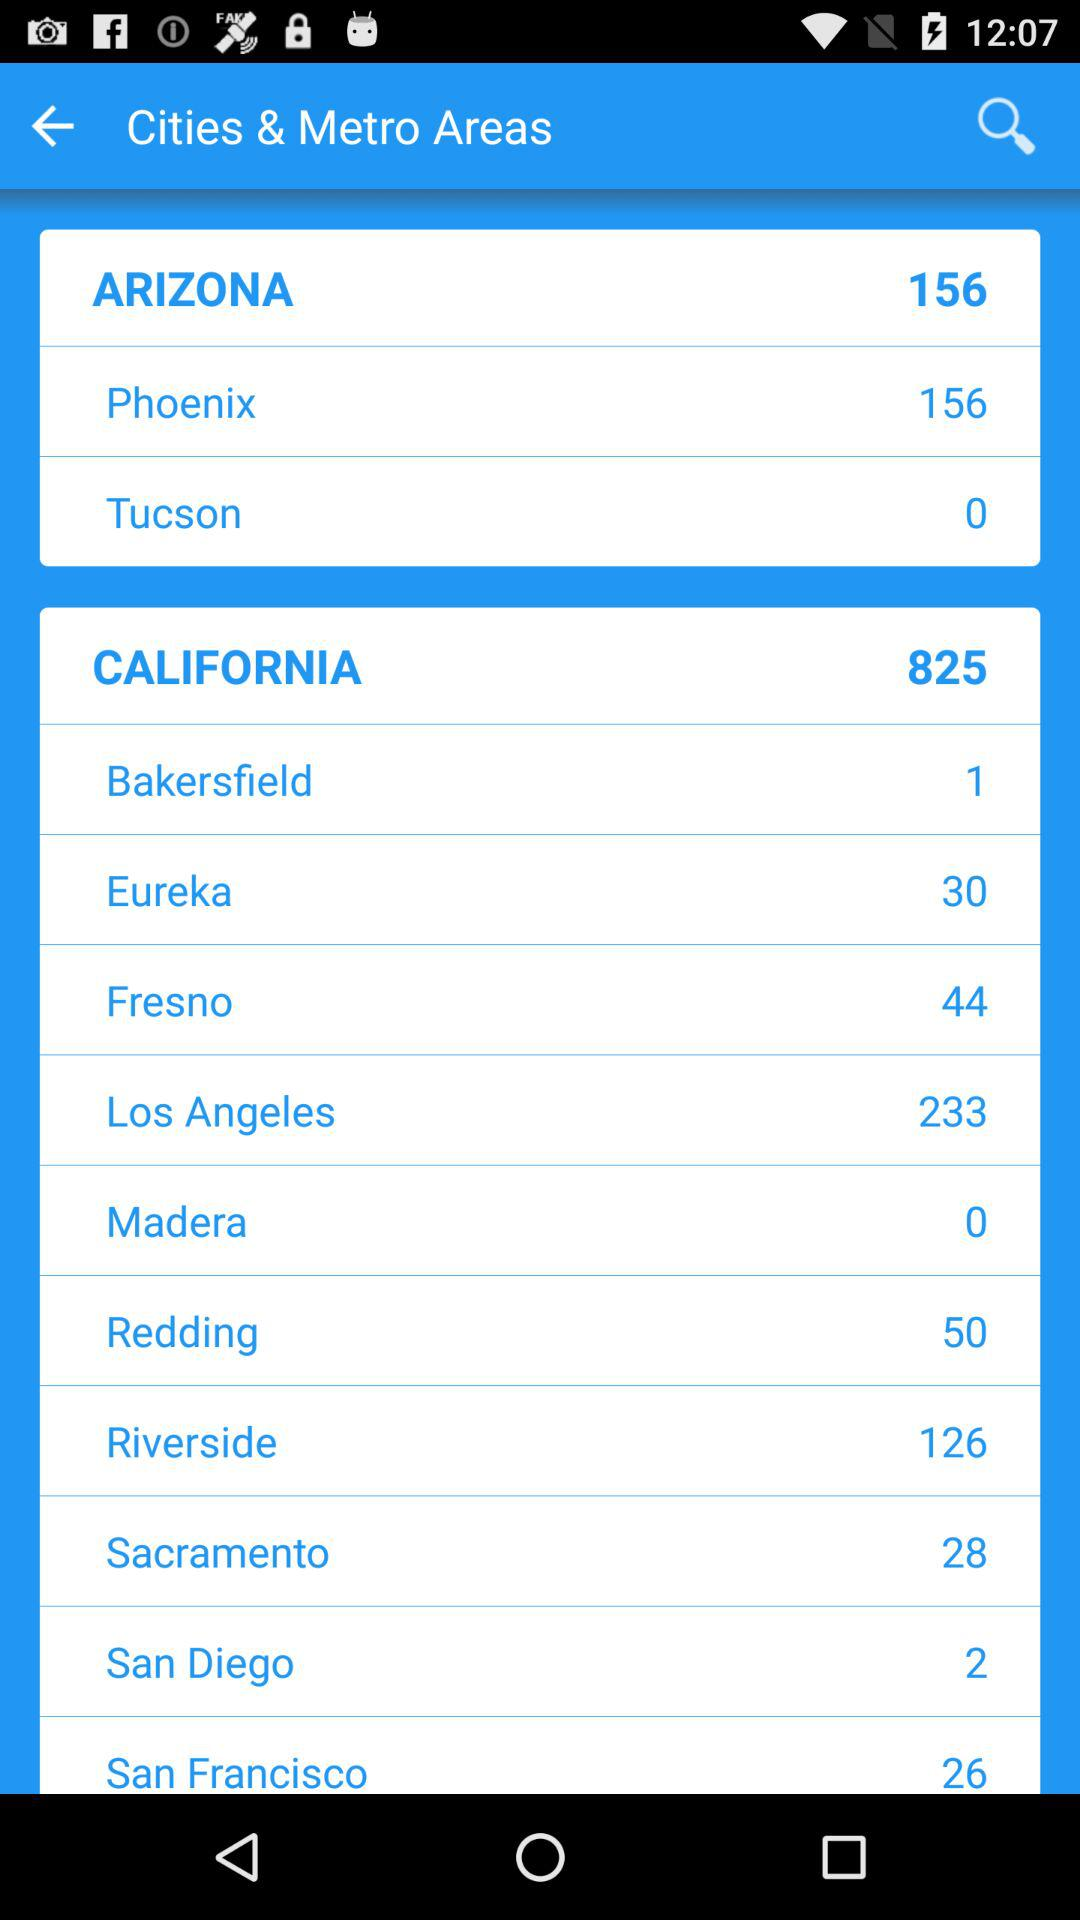How many cities are there in the state of California? There are 825 cities. 